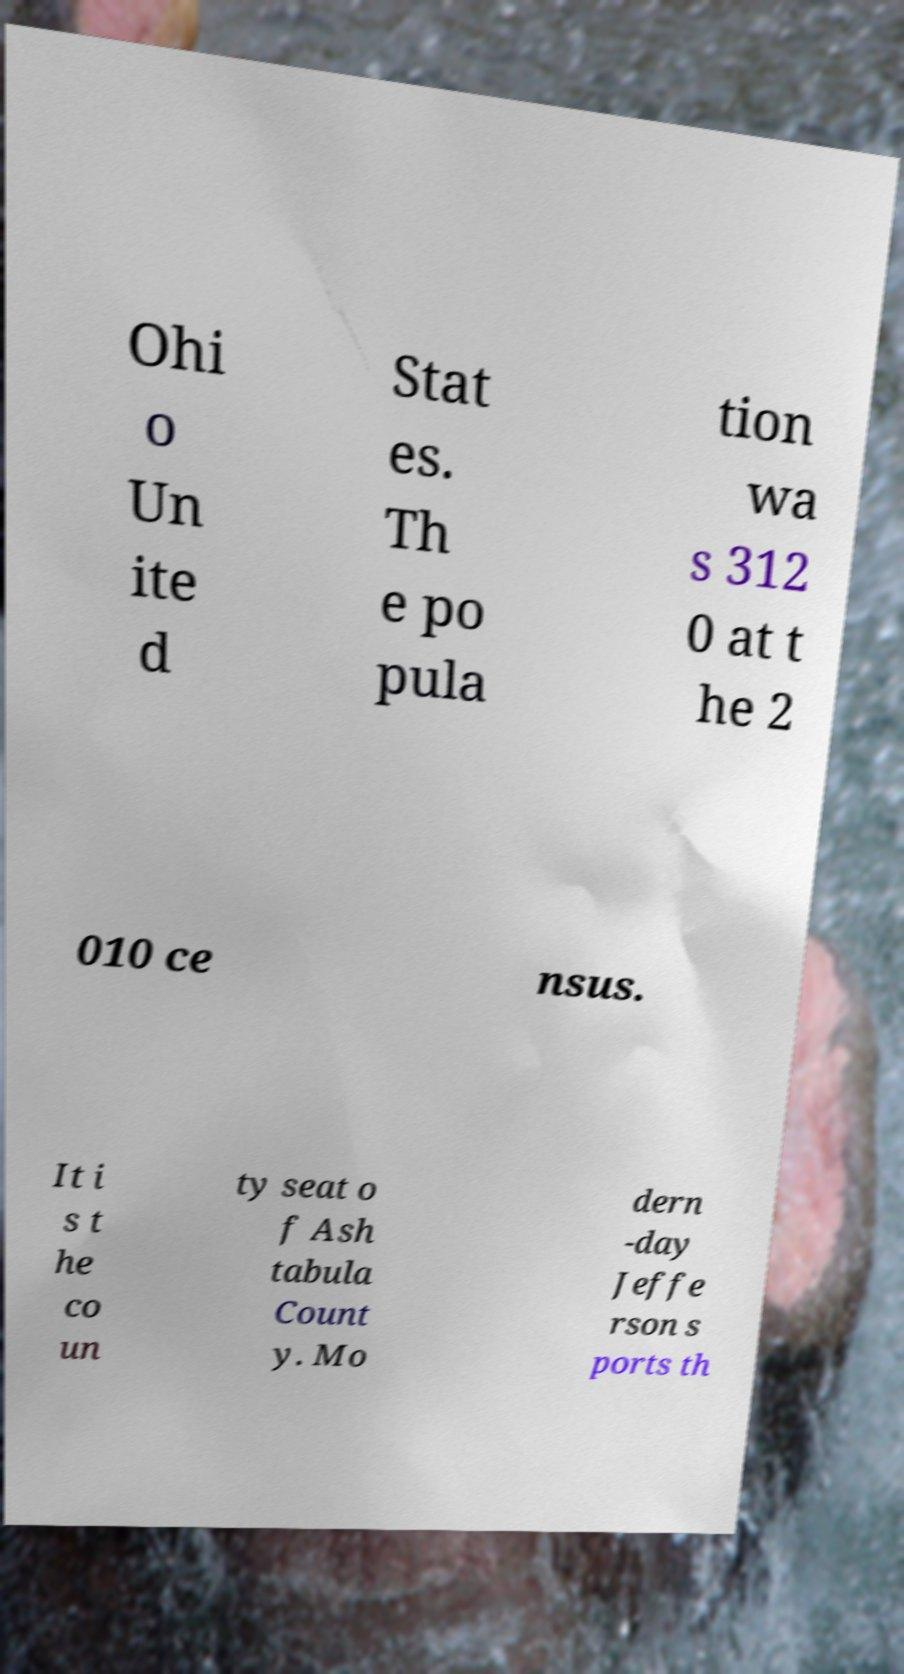There's text embedded in this image that I need extracted. Can you transcribe it verbatim? Ohi o Un ite d Stat es. Th e po pula tion wa s 312 0 at t he 2 010 ce nsus. It i s t he co un ty seat o f Ash tabula Count y. Mo dern -day Jeffe rson s ports th 